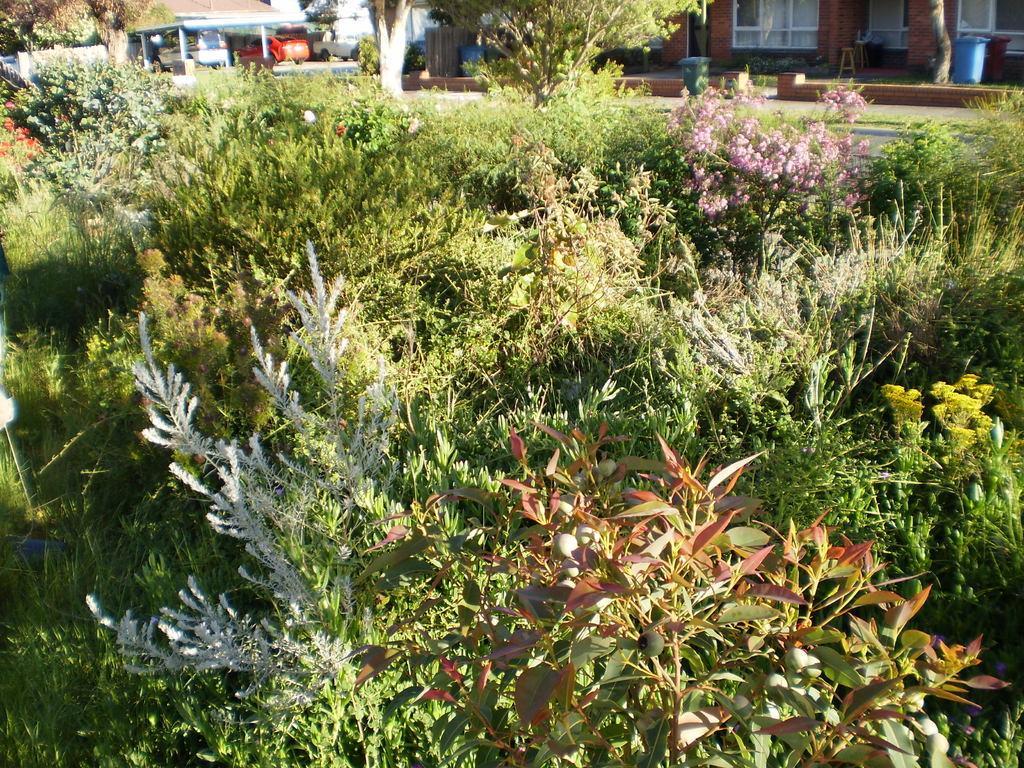Please provide a concise description of this image. In this image we can see a group of plants and some flowers. On the top of the image we can see the trash bins, the bark of the trees, vehicles on the ground, a roof with some poles and a building. 